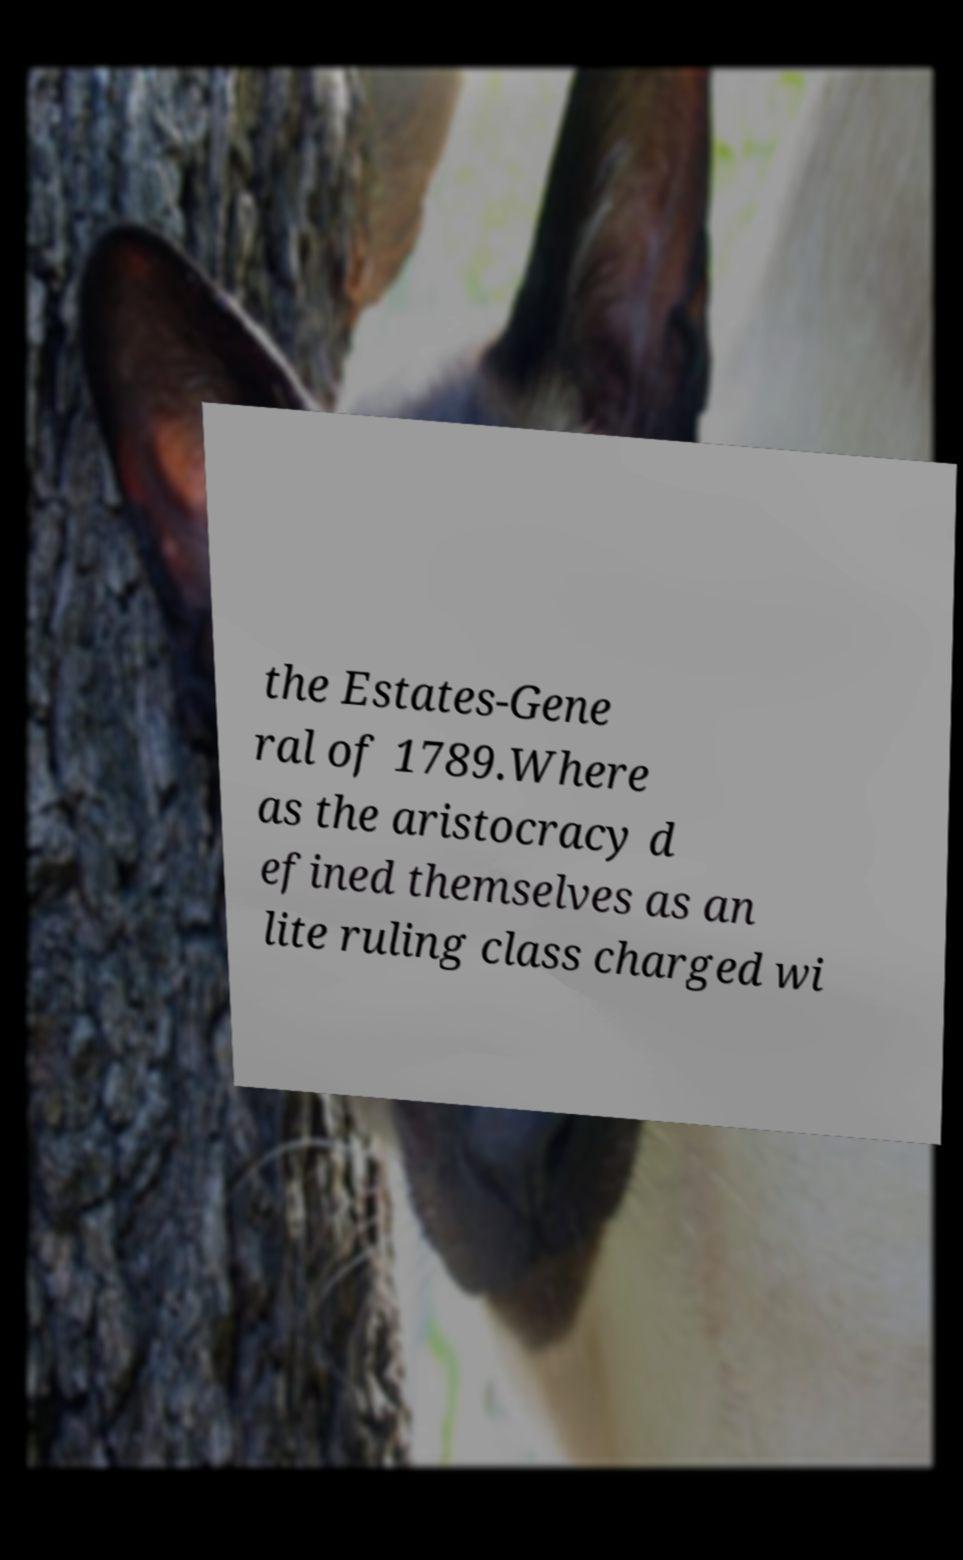Please identify and transcribe the text found in this image. the Estates-Gene ral of 1789.Where as the aristocracy d efined themselves as an lite ruling class charged wi 